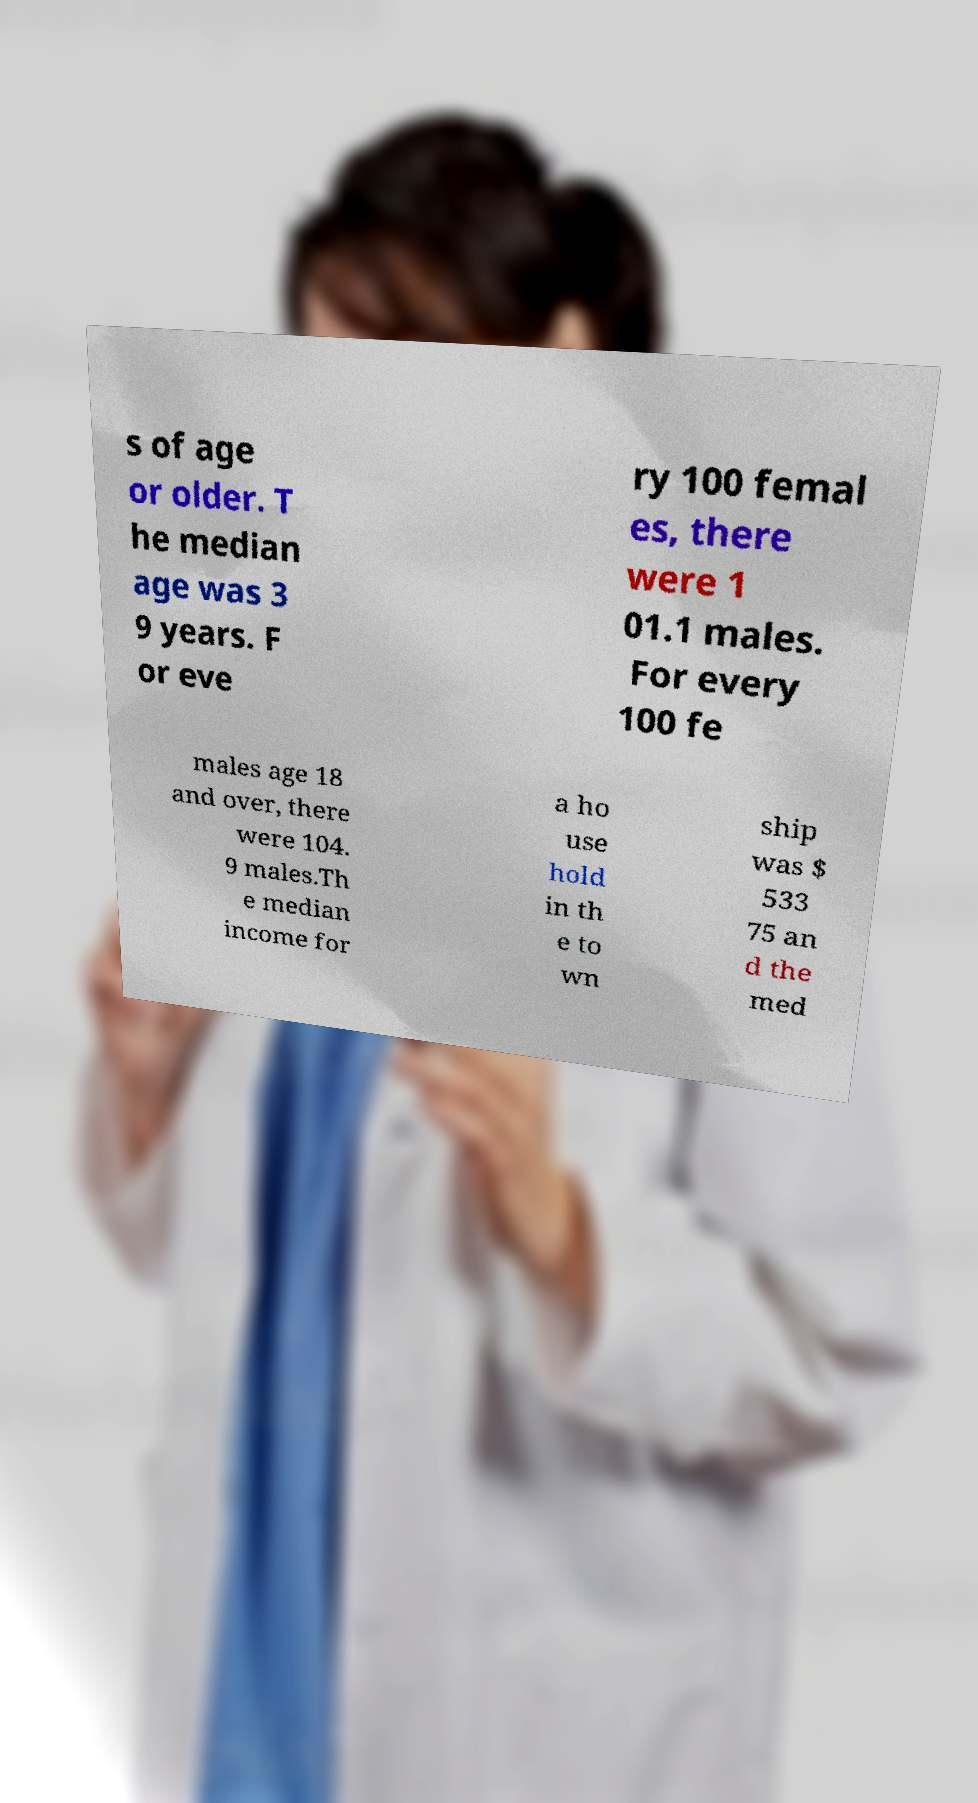Can you read and provide the text displayed in the image?This photo seems to have some interesting text. Can you extract and type it out for me? s of age or older. T he median age was 3 9 years. F or eve ry 100 femal es, there were 1 01.1 males. For every 100 fe males age 18 and over, there were 104. 9 males.Th e median income for a ho use hold in th e to wn ship was $ 533 75 an d the med 